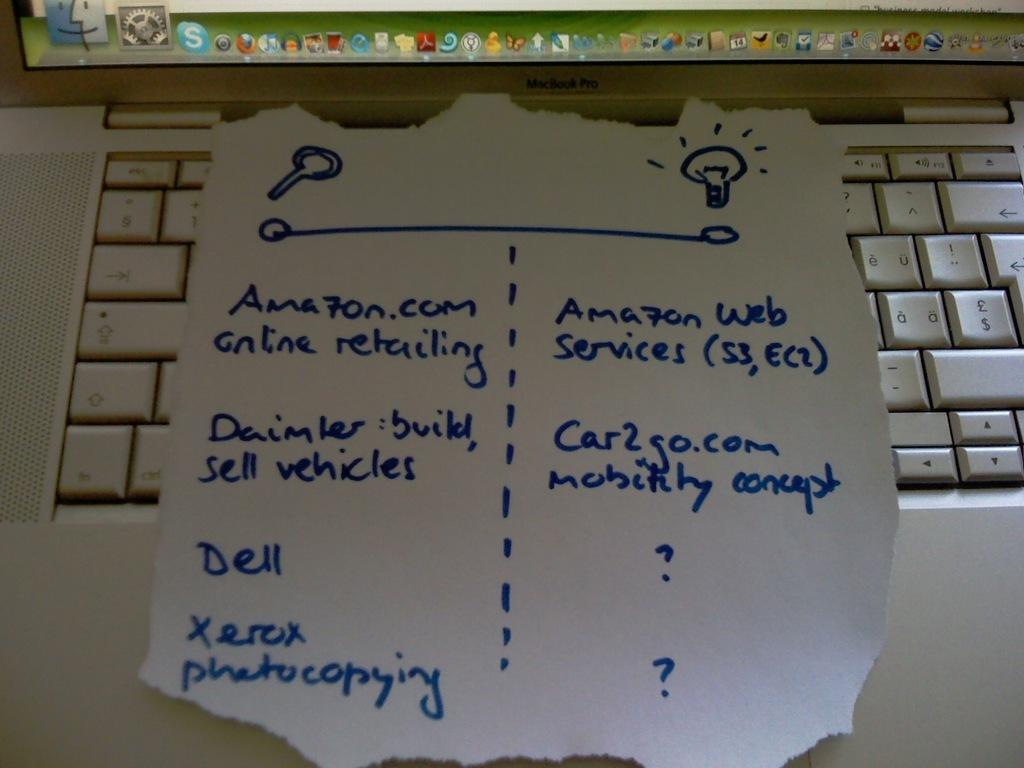<image>
Describe the image concisely. A ripped sheet of paper has information about online retailing and mobility concepts on it. 